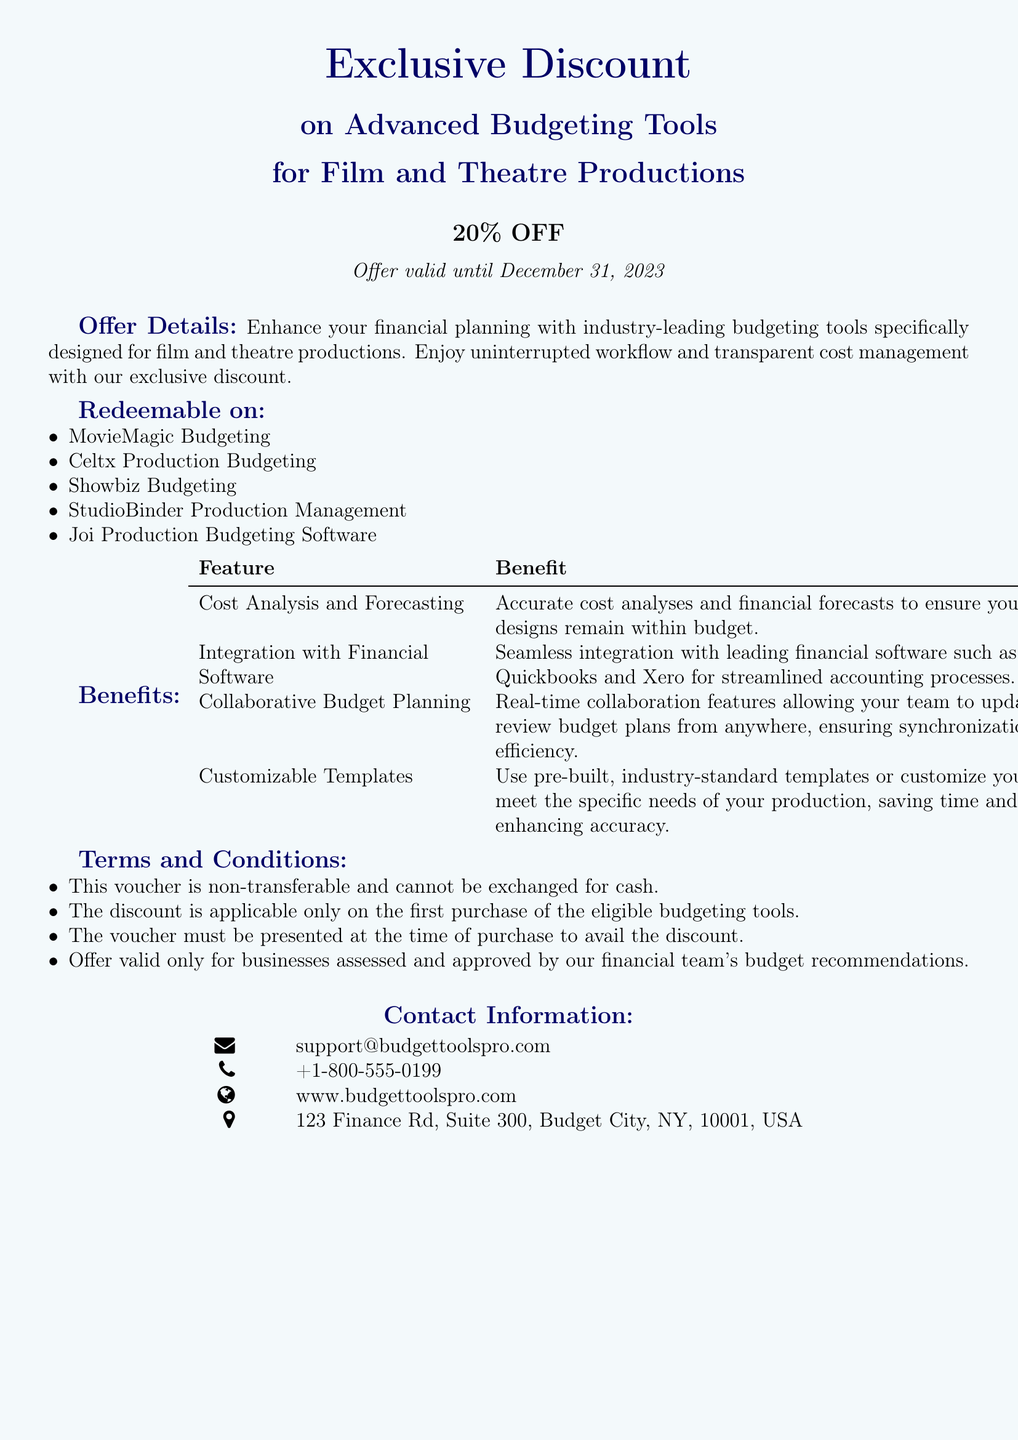What is the discount offered on advanced budgeting tools? The voucher states that there is a 20% discount on advanced budgeting tools for film and theatre productions.
Answer: 20% OFF What is the expiration date of the offer? The document indicates that the offer is valid until December 31, 2023.
Answer: December 31, 2023 Name one budgeting tool that is redeemable with this voucher. The document lists multiple budgeting tools, including MovieMagic Budgeting as one option.
Answer: MovieMagic Budgeting What type of documents must the voucher be presented with? The terms state that the voucher must be presented at the time of purchase to avail the discount.
Answer: At the time of purchase How many benefits are listed under the benefits section? The document includes four features along with their corresponding benefits.
Answer: Four Is the voucher transferable? The terms and conditions specify that this voucher is non-transferable.
Answer: No What is required for businesses to avail themselves of the voucher? It states that the offer is valid only for businesses assessed and approved by the financial team's budget recommendations.
Answer: Approval by budget recommendations Where can customers contact support? The contact information section contains an email address, which is support@budgettoolspro.com for customer inquiries.
Answer: support@budgettoolspro.com What feature allows real-time collaboration? The benefit regarding collaborative budget planning mentions real-time collaboration features.
Answer: Collaborative Budget Planning Which city is listed in the contact information? The address provided in the contact information indicates that the office is in Budget City, NY.
Answer: Budget City, NY 